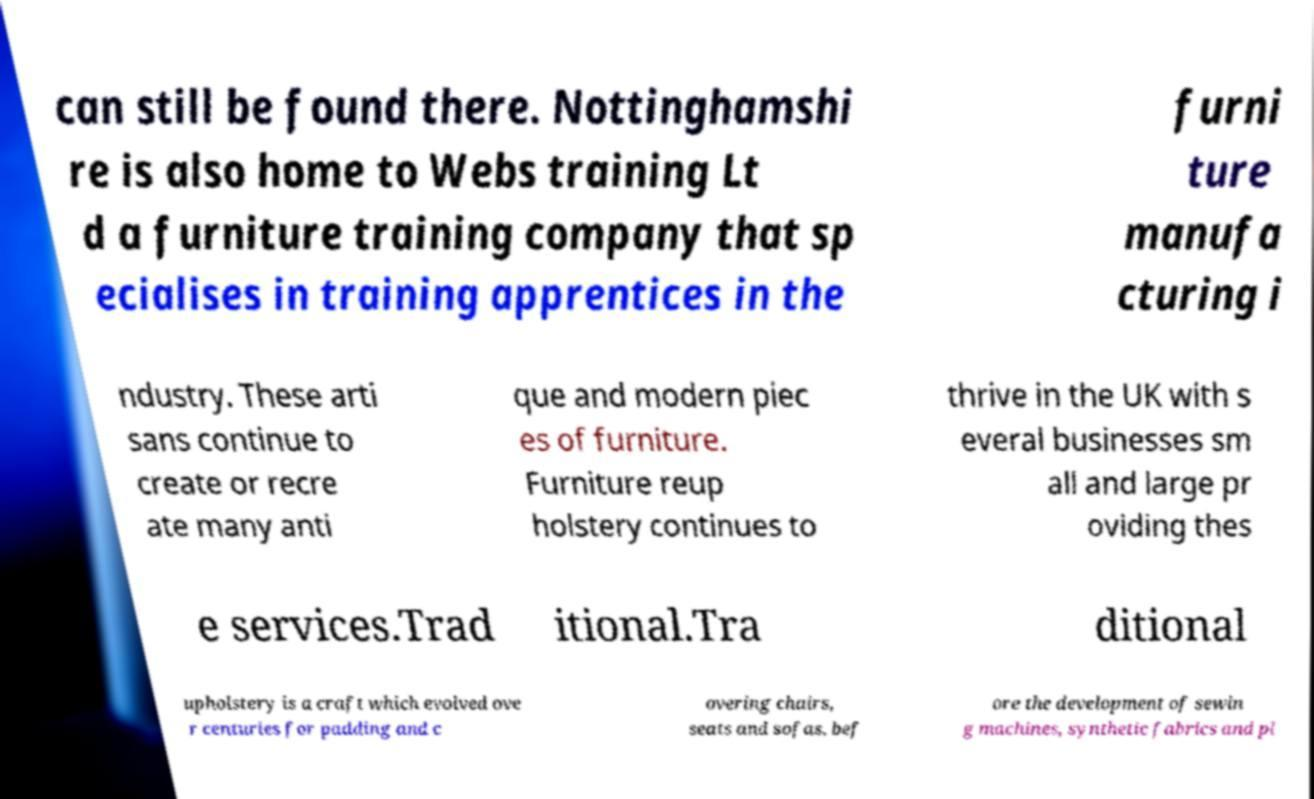There's text embedded in this image that I need extracted. Can you transcribe it verbatim? can still be found there. Nottinghamshi re is also home to Webs training Lt d a furniture training company that sp ecialises in training apprentices in the furni ture manufa cturing i ndustry. These arti sans continue to create or recre ate many anti que and modern piec es of furniture. Furniture reup holstery continues to thrive in the UK with s everal businesses sm all and large pr oviding thes e services.Trad itional.Tra ditional upholstery is a craft which evolved ove r centuries for padding and c overing chairs, seats and sofas, bef ore the development of sewin g machines, synthetic fabrics and pl 